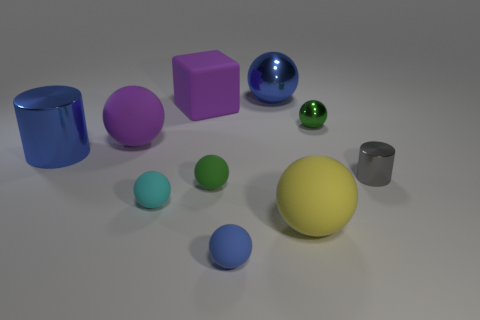Are any small blue rubber spheres visible? Yes, there is one small blue rubber sphere in the image, positioned closer to the foreground on the right side among a collection of various geometric shapes. 